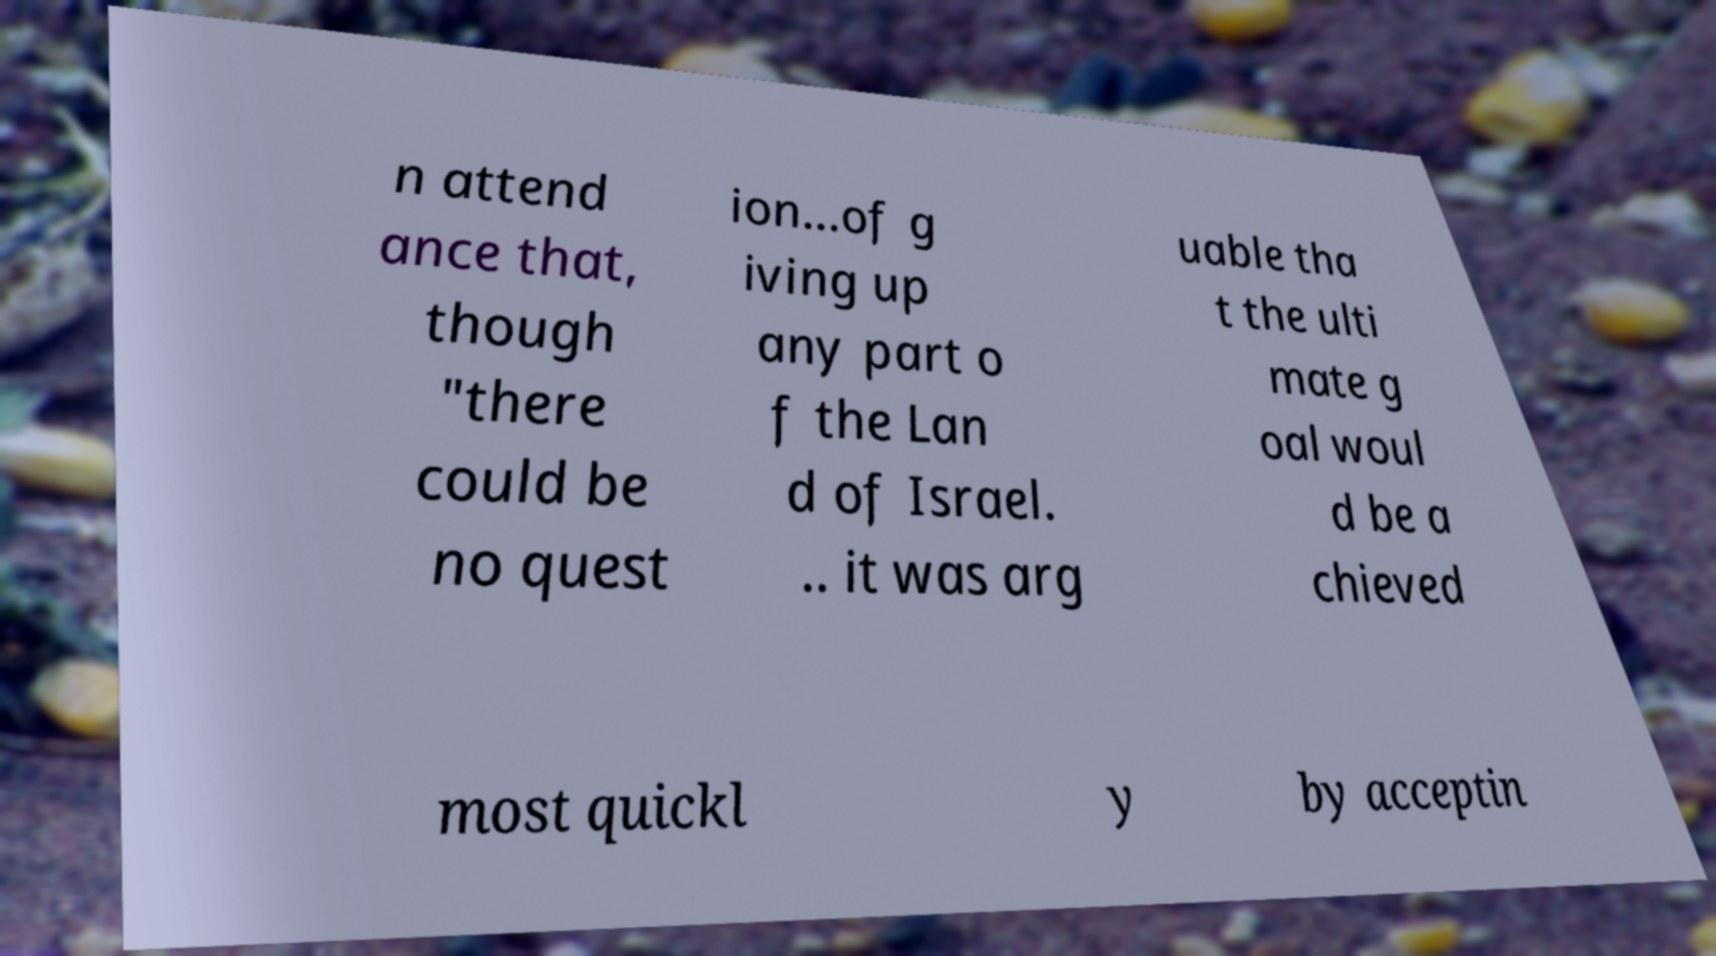For documentation purposes, I need the text within this image transcribed. Could you provide that? n attend ance that, though "there could be no quest ion...of g iving up any part o f the Lan d of Israel. .. it was arg uable tha t the ulti mate g oal woul d be a chieved most quickl y by acceptin 